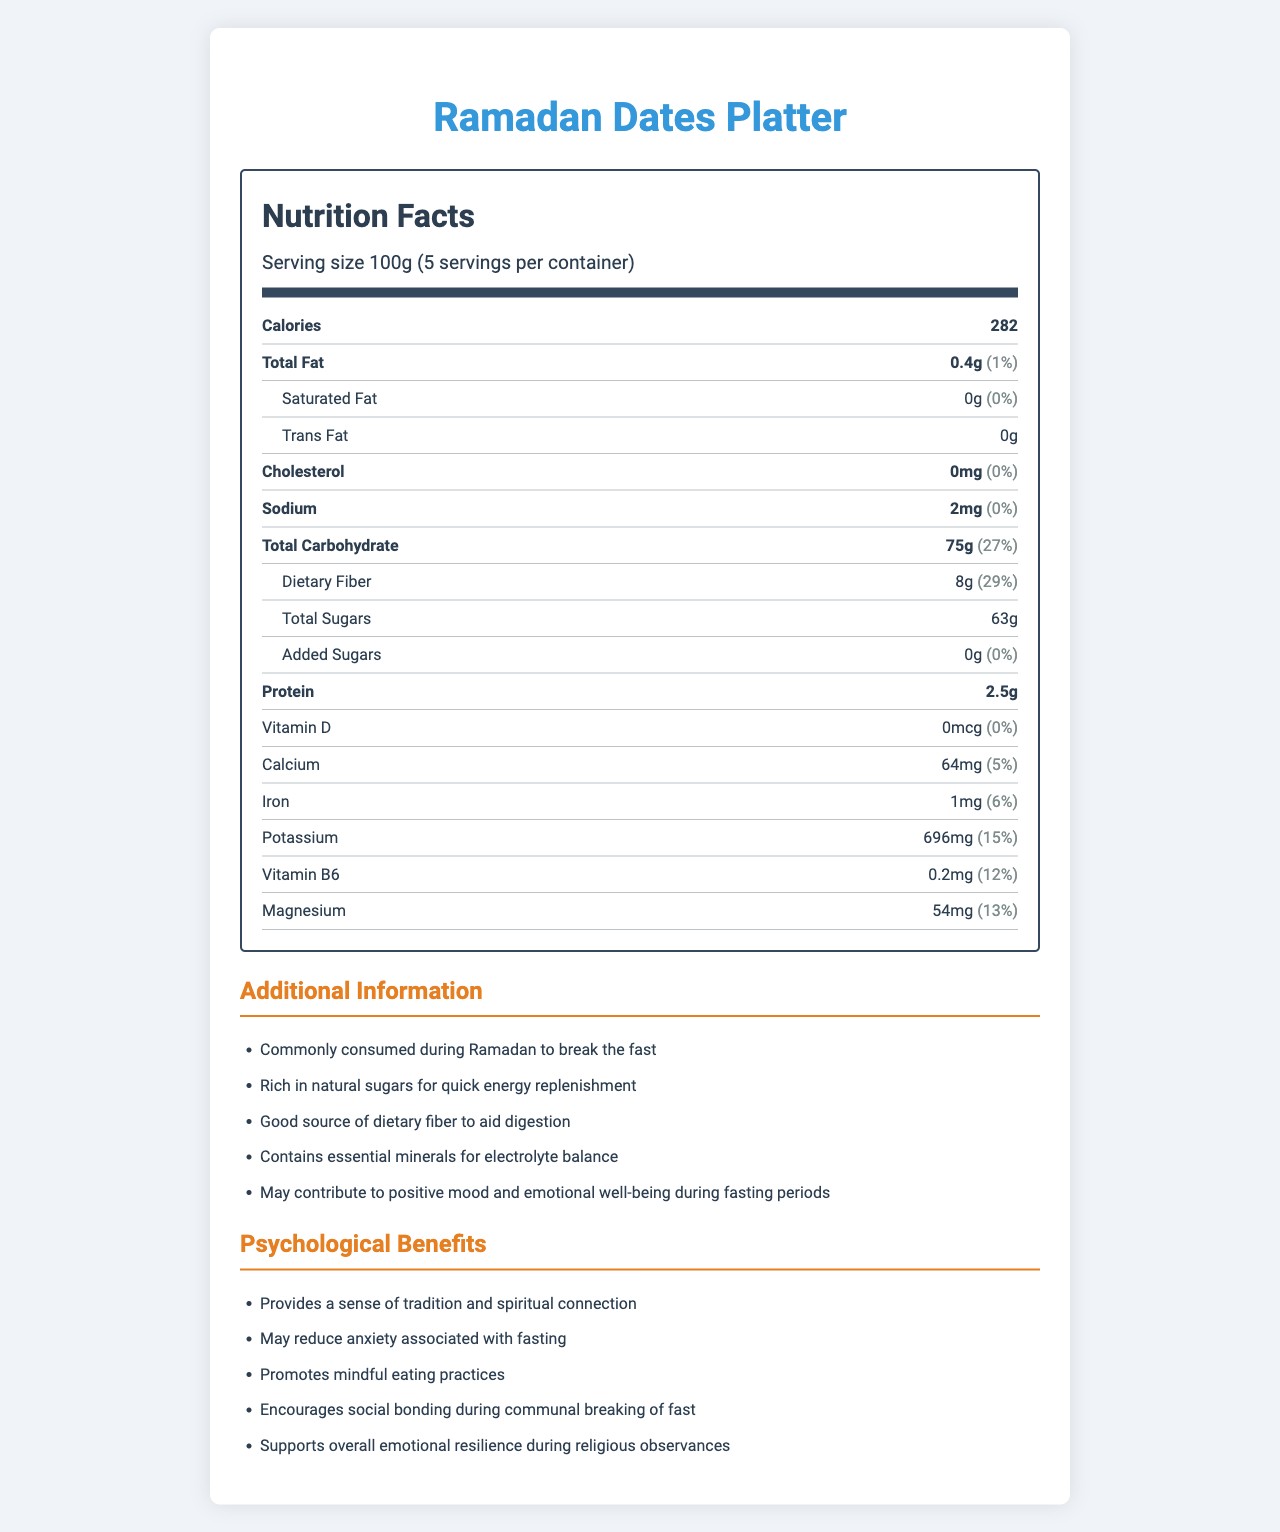what is the serving size of the Ramadan Dates Platter? The serving size is listed in the serving information section as "Serving size 100g".
Answer: 100g how many servings per container are there? The number of servings per container is given in the serving information section as "5".
Answer: 5 what is the primary nutritional component by weight in the Ramadan Dates Platter? The primary nutritional component by weight is the Total Carbohydrate, listed as 75g.
Answer: Total Carbohydrate what is the total amount of added sugars in the product? The amount of added sugars is specified under the carbohydrate section as "Added Sugars: 0g".
Answer: 0g what is the amount of dietary fiber per serving and its daily value percentage? The dietary fiber amount is listed as "8g" and its daily value percentage is given as "29%".
Answer: 8g (29%) which mineral is present in the highest amount in this product? Potassium is listed with the highest amount of 696mg compared to other minerals like iron, calcium, and magnesium.
Answer: Potassium how many calories are there per serving? The number of calories per serving is listed in the main nutrient section as "Calories: 282".
Answer: 282 what is the daily value percentage of protein in the product? The document does not provide the daily value percentage for protein.
Answer: Not Provided what psychological benefit is mentioned that relates to social activities? The psychological benefit section mentions, "Encourages social bonding during communal breaking of fast".
Answer: Encourages social bonding during communal breaking of fast what is the total amount of calcium in the product and its daily value percentage? The amount of calcium is listed as "64mg" and its daily value percentage as "5%".
Answer: 64mg (5%) what benefit does dietary fiber provide according to the additional information? The additional information mentions that dietary fiber "aids digestion".
Answer: Aids digestion what is the primary purpose of consuming Ramadan Dates Platter during Ramadan according to the additional information? The additional information states that it is "Commonly consumed during Ramadan to break the fast".
Answer: To break the fast how does the product contribute to emotional well-being during fasting periods? The additional information states that the product "May contribute to positive mood and emotional well-being during fasting periods".
Answer: May contribute to positive mood and emotional well-being does the product contain any Vitamin D? The document lists Vitamin D as "0mcg" with a daily value of "0%".
Answer: No which nutrient has the highest daily value percentage? A. Total Carbohydrate B. Dietary Fiber C. Potassium D. Magnesium The daily value percentage of dietary fiber is 29%, which is higher than the other listed options: Total Carbohydrate (27%), Potassium (15%), and Magnesium (13%).
Answer: B. Dietary Fiber which of the following is not a psychological benefit mentioned? I. Provides a sense of tradition II. Improves physical strength III. Promotes mindful eating IV. Reduces anxiety. The psychological benefits mentioned include I, III, and IV, but "Improves physical strength" is not listed.
Answer: II. Improves physical strength is there any cholesterol in the Ramadan Dates Platter? The amount of cholesterol is listed as "0mg" with a daily value of "0%".
Answer: No summarize the main information presented in the document. The summary combines key points about the nutritional profile and psychological benefits of the product, providing a holistic understanding of the information presented in the document.
Answer: The document provides detailed nutritional and psychological information about the Ramadan Dates Platter, a food commonly consumed to break the fast during Ramadan. It includes serving size, calories, macronutrients (fats, carbohydrates, proteins), vitamins and minerals, as well as additional information highlighting its benefits such as aiding digestion and contributing to emotional well-being. Psychological benefits such as promoting tradition and social bonding are also listed. does the document mention the origin or brand of the Ramadan Dates Platter? The document does not provide any details on the origin or branding of the product.
Answer: Not enough information 